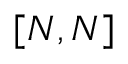Convert formula to latex. <formula><loc_0><loc_0><loc_500><loc_500>[ N , N ]</formula> 